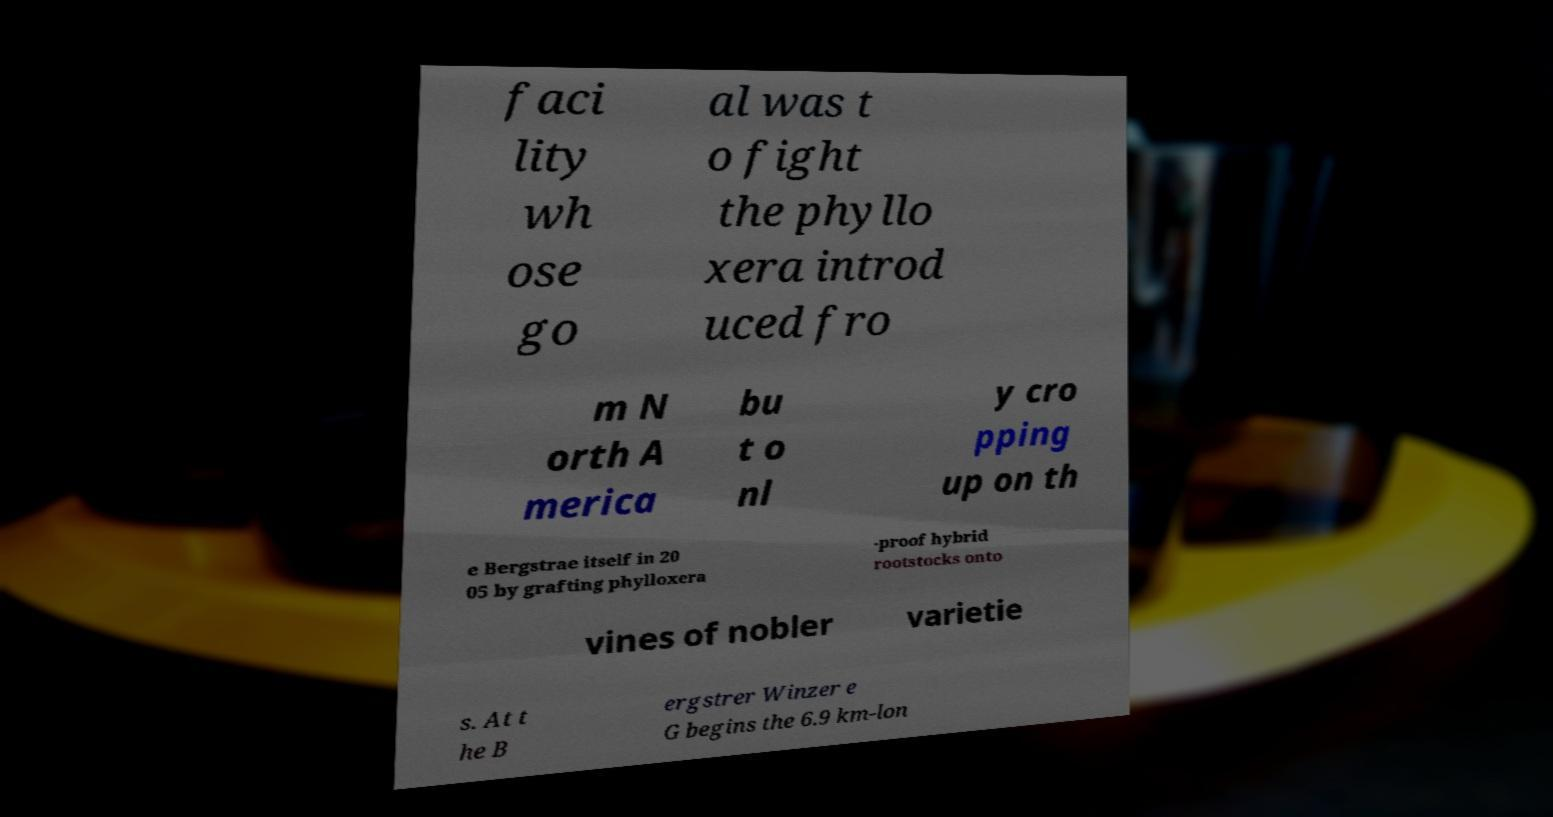What messages or text are displayed in this image? I need them in a readable, typed format. faci lity wh ose go al was t o fight the phyllo xera introd uced fro m N orth A merica bu t o nl y cro pping up on th e Bergstrae itself in 20 05 by grafting phylloxera -proof hybrid rootstocks onto vines of nobler varietie s. At t he B ergstrer Winzer e G begins the 6.9 km-lon 